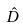<formula> <loc_0><loc_0><loc_500><loc_500>\hat { D }</formula> 